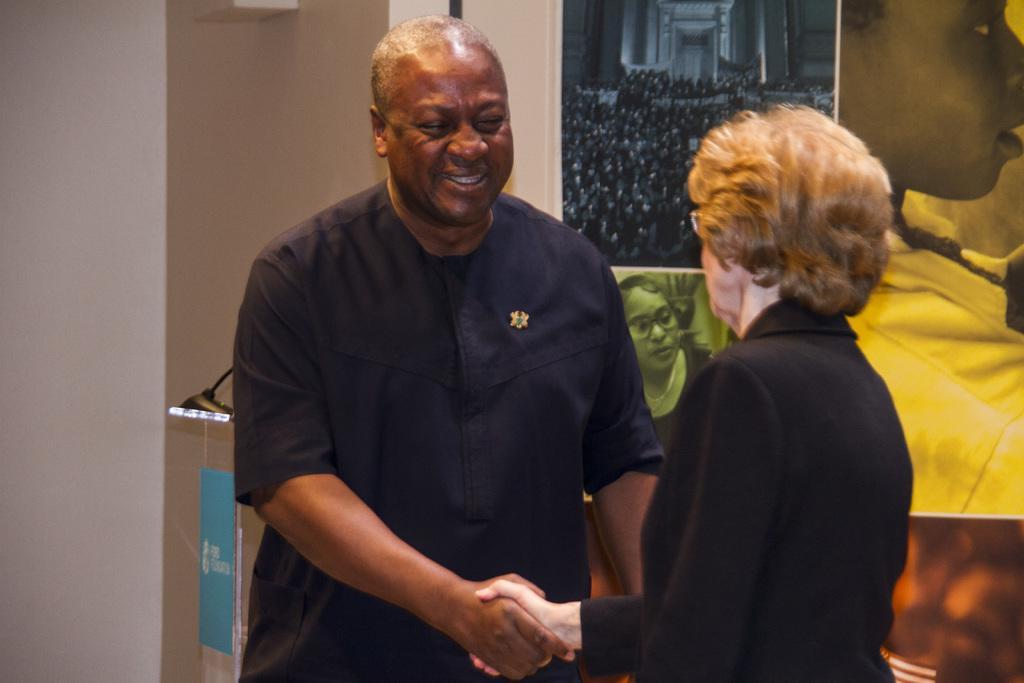Can you describe this image briefly? In this image in the front there are persons standing and shaking hands with each other and the in the center there is a man standing and smiling. In the background there are posters and on the left side there is an object which is black in colour and there is a wall which is white in colour. 